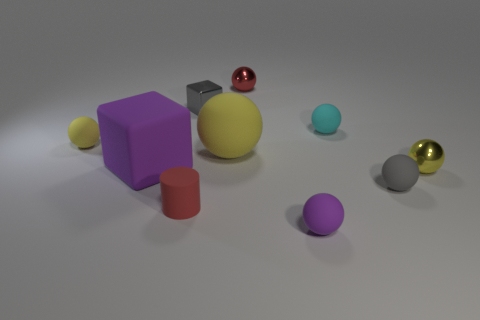There is a yellow ball that is left of the block behind the tiny cyan sphere; is there a purple thing that is right of it?
Offer a terse response. Yes. There is a cyan object that is behind the large purple matte block; does it have the same shape as the small gray rubber object?
Provide a short and direct response. Yes. There is a big ball that is made of the same material as the red cylinder; what color is it?
Offer a terse response. Yellow. What number of gray things have the same material as the purple cube?
Your answer should be compact. 1. There is a matte object behind the tiny yellow thing to the left of the gray thing behind the small gray rubber ball; what is its color?
Your response must be concise. Cyan. Does the cyan sphere have the same size as the red rubber cylinder?
Provide a succinct answer. Yes. Are there any other things that have the same shape as the big yellow object?
Provide a succinct answer. Yes. What number of things are tiny things right of the red ball or big things?
Your answer should be compact. 6. Does the small purple object have the same shape as the large purple object?
Offer a very short reply. No. How many other things are the same size as the metallic block?
Ensure brevity in your answer.  7. 